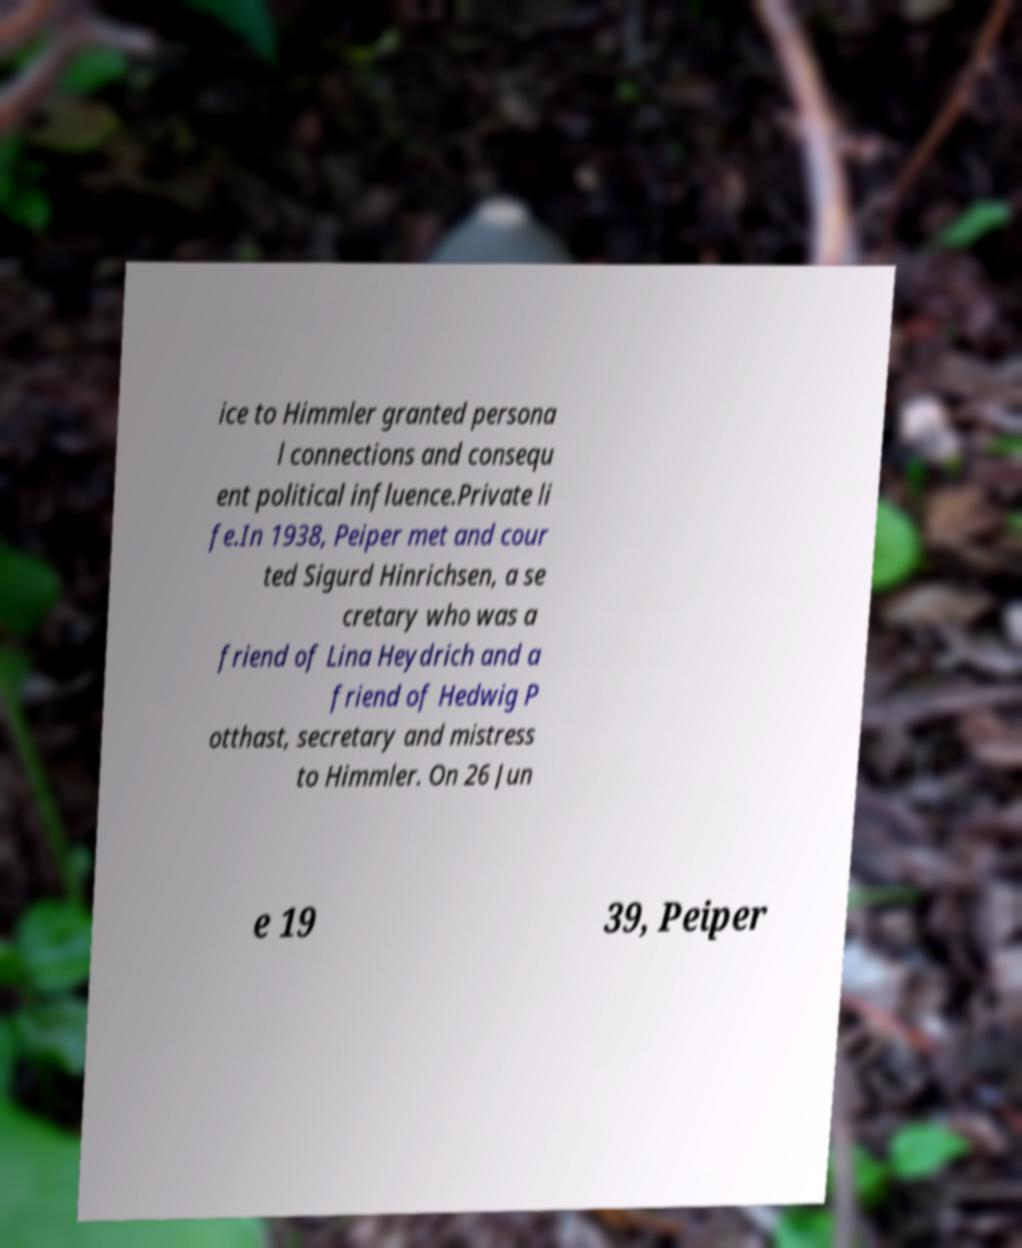Please identify and transcribe the text found in this image. ice to Himmler granted persona l connections and consequ ent political influence.Private li fe.In 1938, Peiper met and cour ted Sigurd Hinrichsen, a se cretary who was a friend of Lina Heydrich and a friend of Hedwig P otthast, secretary and mistress to Himmler. On 26 Jun e 19 39, Peiper 